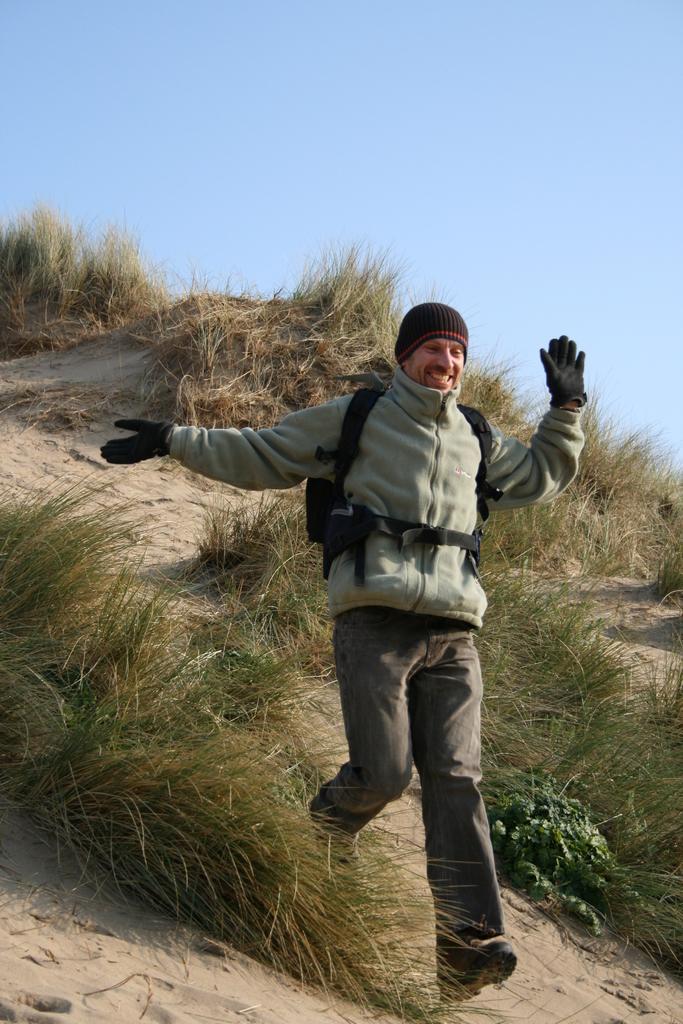Can you describe this image briefly? In this image we can see a person running on the hill, shrubs and sky. 